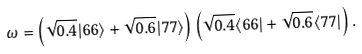Convert formula to latex. <formula><loc_0><loc_0><loc_500><loc_500>\omega = \left ( \sqrt { 0 . 4 } | 6 6 \rangle + \sqrt { 0 . 6 } | 7 7 \rangle \right ) \left ( \sqrt { 0 . 4 } \langle 6 6 | + \sqrt { 0 . 6 } \langle 7 7 | \right ) .</formula> 